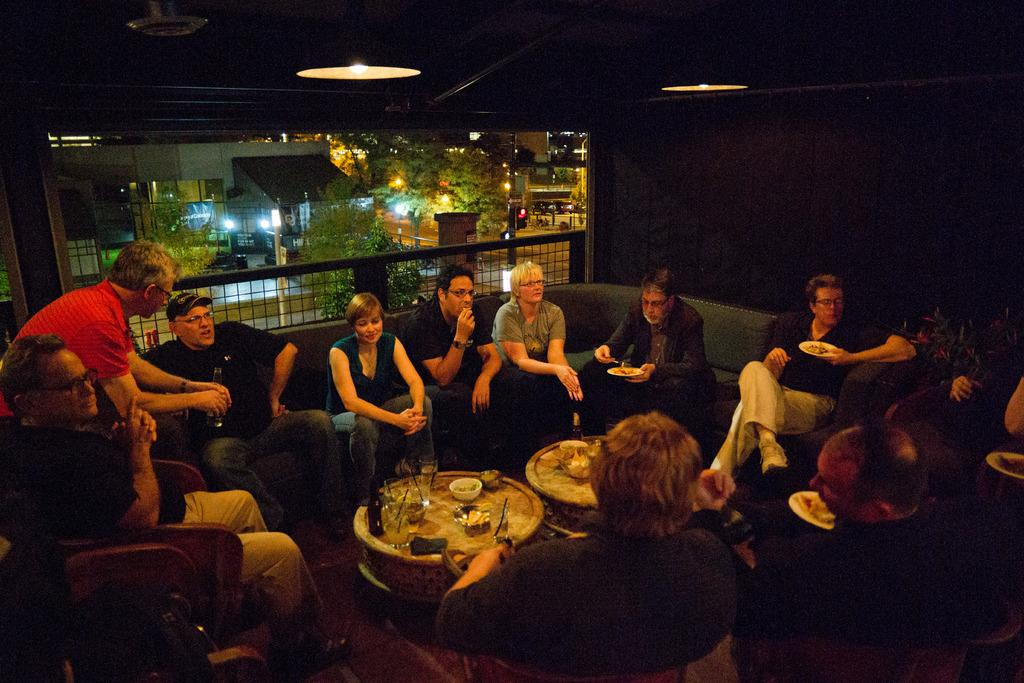What are the people in the image doing? There is a group of people sitting on a couch in the image. What is in front of the group of people? The group of people is in front of a table. What can be seen in the background of the image? Buildings and trees are visible in the image. What type of pathway is present in the image? There is a road in the image. What type of basketball skills are being demonstrated by the porter in the image? There is no porter or basketball present in the image. What type of bun is being served on the table in the image? There is no bun visible on the table in the image. 